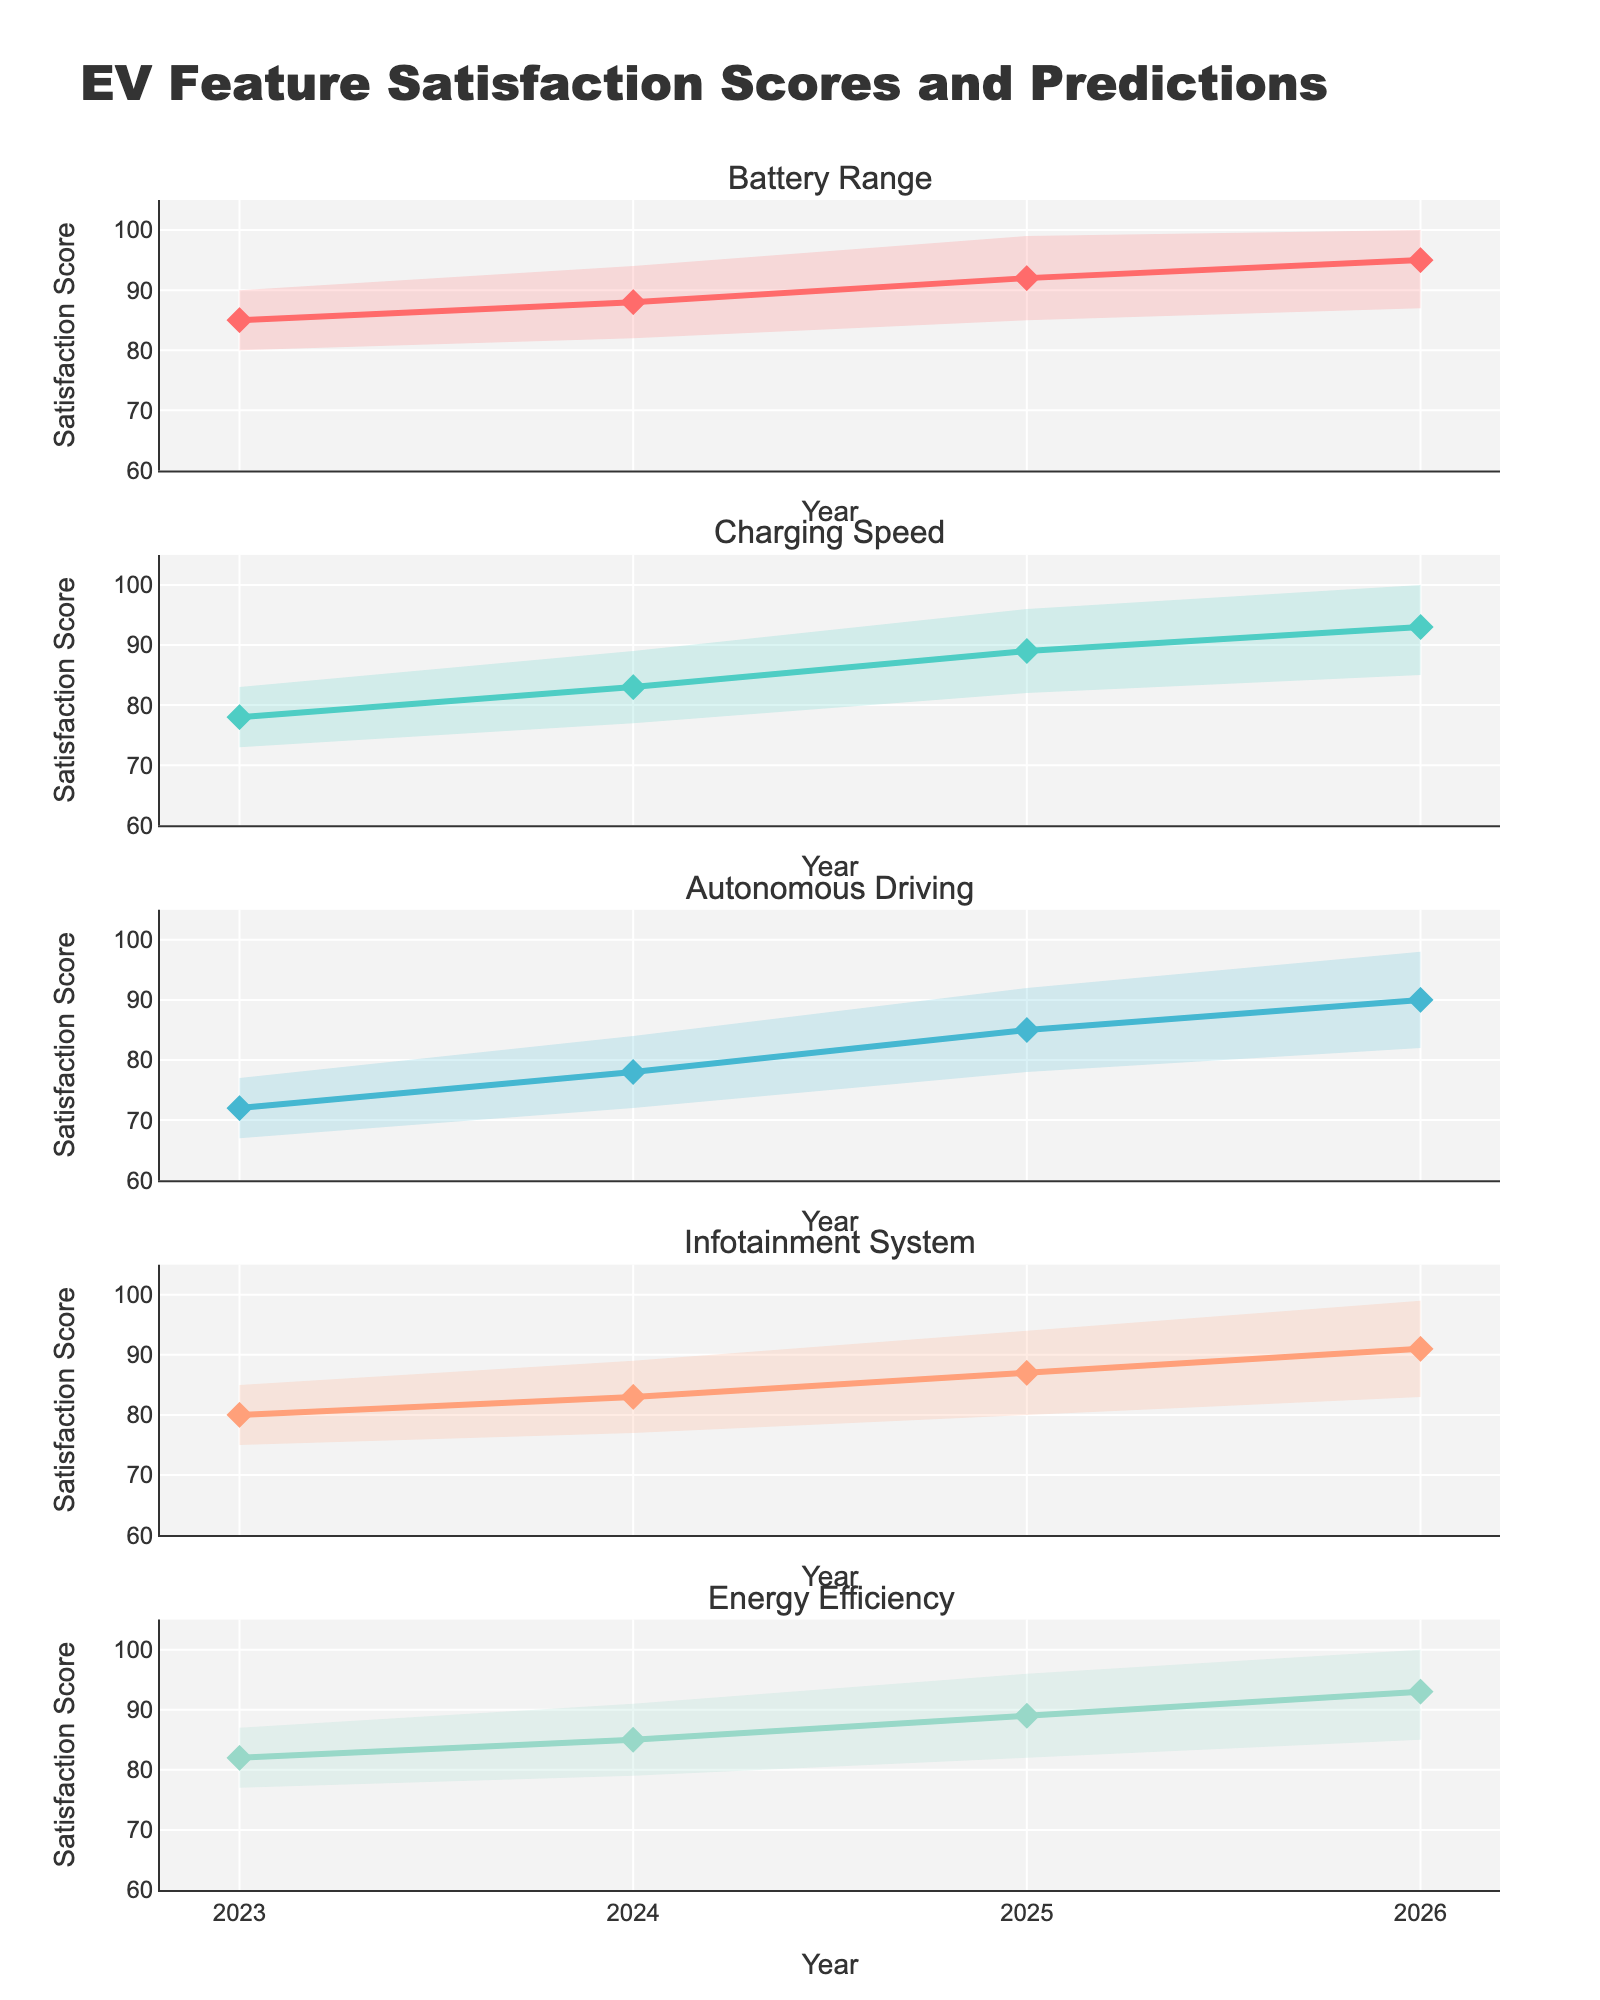Which feature has the highest satisfaction score in 2023? The feature with the highest satisfaction score in 2023 can be identified by looking at the satisfaction scores for each feature in 2023. The scores are as follows: Battery Range (85), Charging Speed (78), Autonomous Driving (72), Infotainment System (80), Energy Efficiency (82). The highest score is 85 for Battery Range.
Answer: Battery Range What is the average satisfaction score for the Charging Speed feature across the years? First, we sum the satisfaction scores for Charging Speed from 2023 to 2026: 78 (2023) + 83 (2024) + 89 (2025) + 93 (2026) = 343. Then, we divide by the number of years (4): 343 / 4 = 85.75.
Answer: 85.75 How does the satisfaction score for Autonomous Driving in 2026 compare to its score in 2023? The satisfaction score for Autonomous Driving in 2026 is 90, and in 2023 it is 72. To compare, we subtract the 2023 score from the 2026 score: 90 - 72 = 18. So, there is an increase of 18 points.
Answer: It increased by 18 points Which feature shows the most improvement in satisfaction score from 2023 to 2026? To find the feature with the most improvement, we need to calculate the difference between the 2026 and 2023 scores for each feature:
Battery Range: 95 - 85 = 10
Charging Speed: 93 - 78 = 15
Autonomous Driving: 90 - 72 = 18
Infotainment System: 91 - 80 = 11
Energy Efficiency: 93 - 82 = 11
Autonomous Driving shows the most improvement with a difference of 18 points.
Answer: Autonomous Driving What is the range of the predicted satisfaction score for Energy Efficiency in 2026? The range is determined by the Upper Bound and Lower Bound values for Energy Efficiency in 2026. The Upper Bound is 100 and the Lower Bound is 85. The range is 100 - 85 = 15.
Answer: 15 Between 2024 and 2025, which feature has the smallest increase in satisfaction score? To find which feature has the smallest increase, we calculate the difference between the 2025 and 2024 satisfaction scores for each feature:
Battery Range: 92 - 88 = 4
Charging Speed: 89 - 83 = 6
Autonomous Driving: 85 - 78 = 7
Infotainment System: 87 - 83 = 4
Energy Efficiency: 89 - 85 = 4
Battery Range, Infotainment System, and Energy Efficiency all have the smallest increase of 4 points.
Answer: Battery Range, Infotainment System, Energy Efficiency 